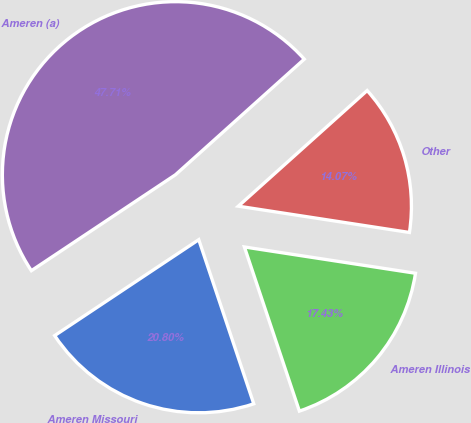Convert chart to OTSL. <chart><loc_0><loc_0><loc_500><loc_500><pie_chart><fcel>Ameren Missouri<fcel>Ameren Illinois<fcel>Other<fcel>Ameren (a)<nl><fcel>20.8%<fcel>17.43%<fcel>14.07%<fcel>47.71%<nl></chart> 